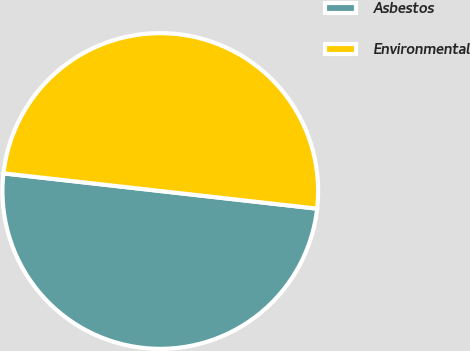<chart> <loc_0><loc_0><loc_500><loc_500><pie_chart><fcel>Asbestos<fcel>Environmental<nl><fcel>50.0%<fcel>50.0%<nl></chart> 